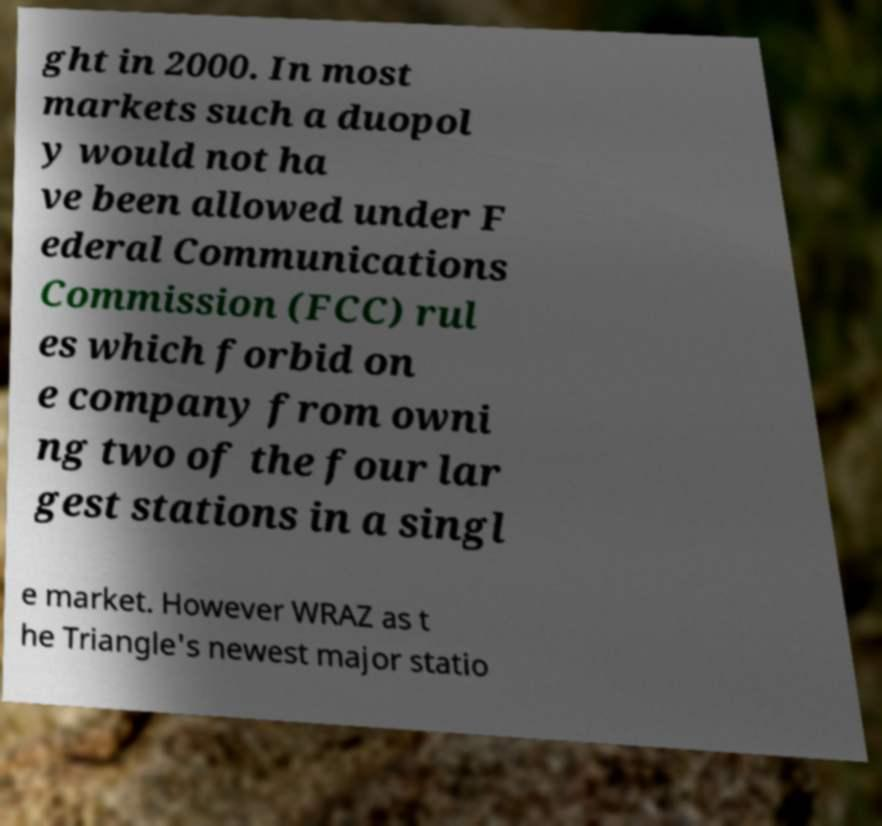What messages or text are displayed in this image? I need them in a readable, typed format. ght in 2000. In most markets such a duopol y would not ha ve been allowed under F ederal Communications Commission (FCC) rul es which forbid on e company from owni ng two of the four lar gest stations in a singl e market. However WRAZ as t he Triangle's newest major statio 